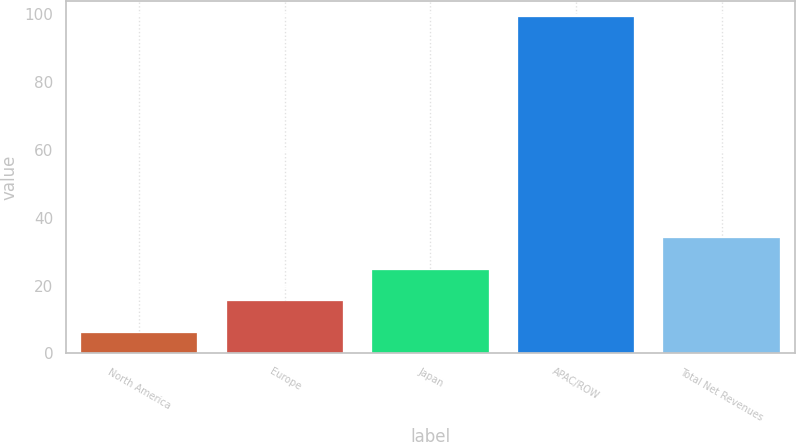Convert chart. <chart><loc_0><loc_0><loc_500><loc_500><bar_chart><fcel>North America<fcel>Europe<fcel>Japan<fcel>APAC/ROW<fcel>Total Net Revenues<nl><fcel>6<fcel>15.3<fcel>24.6<fcel>99<fcel>33.9<nl></chart> 